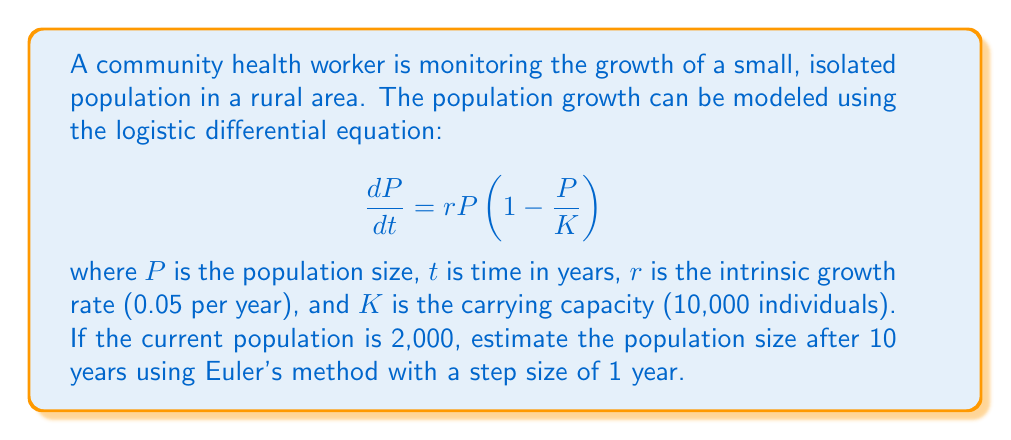Teach me how to tackle this problem. To solve this problem using Euler's method, we'll follow these steps:

1) Euler's method is given by the formula:
   $$P_{n+1} = P_n + h \cdot f(t_n, P_n)$$
   where $h$ is the step size, and $f(t, P) = rP(1 - \frac{P}{K})$

2) Given information:
   - Initial population $P_0 = 2000$
   - Growth rate $r = 0.05$
   - Carrying capacity $K = 10000$
   - Step size $h = 1$ year
   - We need to calculate for 10 years

3) Let's calculate step by step:

   For $n = 0$:
   $$f(t_0, P_0) = 0.05 \cdot 2000 \cdot (1 - \frac{2000}{10000}) = 80$$
   $$P_1 = 2000 + 1 \cdot 80 = 2080$$

   For $n = 1$:
   $$f(t_1, P_1) = 0.05 \cdot 2080 \cdot (1 - \frac{2080}{10000}) = 81.536$$
   $$P_2 = 2080 + 1 \cdot 81.536 = 2161.536$$

   We continue this process for 10 steps. The calculations for the remaining steps are:

   $P_3 = 2244.998$
   $P_4 = 2330.271$
   $P_5 = 2417.219$
   $P_6 = 2505.701$
   $P_7 = 2595.566$
   $P_8 = 2686.663$
   $P_9 = 2778.839$
   $P_{10} = 2871.937$

4) Therefore, after 10 years, the estimated population is approximately 2,872 individuals.
Answer: The estimated population size after 10 years is approximately 2,872 individuals. 